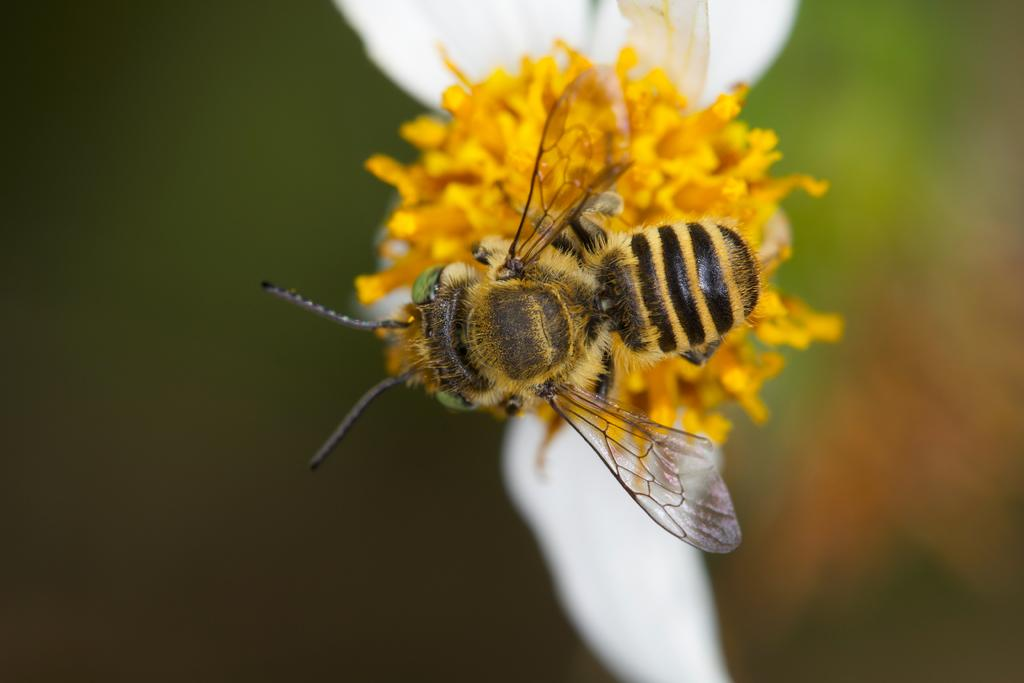What type of insect is in the image? There is a honey bee in the image. What is the honey bee doing in the image? The honey bee is on a yellow and white color flower. Can you describe the background of the image? The background of the image is blurred. How many trees can be seen in the image? There are no trees visible in the image; it features a honey bee on a flower. What is the size of the honey bee in relation to the flower in the image? The size of the honey bee in relation to the flower cannot be determined from the image alone, as there is no reference for scale. 